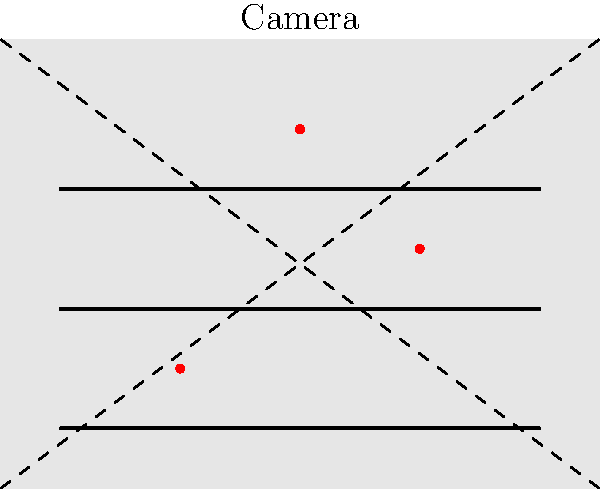In the security camera footage shown above, an employee's movements are tracked by red dots. Which pattern of movement is most suspicious and why? To identify suspicious behavior, we need to analyze the employee's movement pattern:

1. The employee's positions are marked by three red dots at (30,20), (70,40), and (50,60).
2. The store layout shows three horizontal shelves.
3. A normal shopping or restocking pattern would typically follow a more linear path along the shelves.
4. In this case, the employee's movement appears erratic:
   a. They start at the bottom shelf on the left.
   b. Then move diagonally up to the middle shelf on the right.
   c. Finally, they move to the top shelf in the center.
5. This zigzag pattern covers all three shelves quickly and doesn't follow a logical progression.
6. Such movement could indicate the employee is:
   a. Rushing through tasks inefficiently.
   b. Potentially looking for opportunities to steal items from different areas.
   c. Trying to avoid being in one place for too long, possibly to evade detection.
7. The irregular pattern suggests the employee might be more focused on surveying the store layout than performing normal duties.

Given the mistrustful persona of the business owner, this erratic movement pattern would be considered the most suspicious as it deviates from expected behavior and covers multiple areas of the store quickly.
Answer: Zigzag pattern across all shelves 